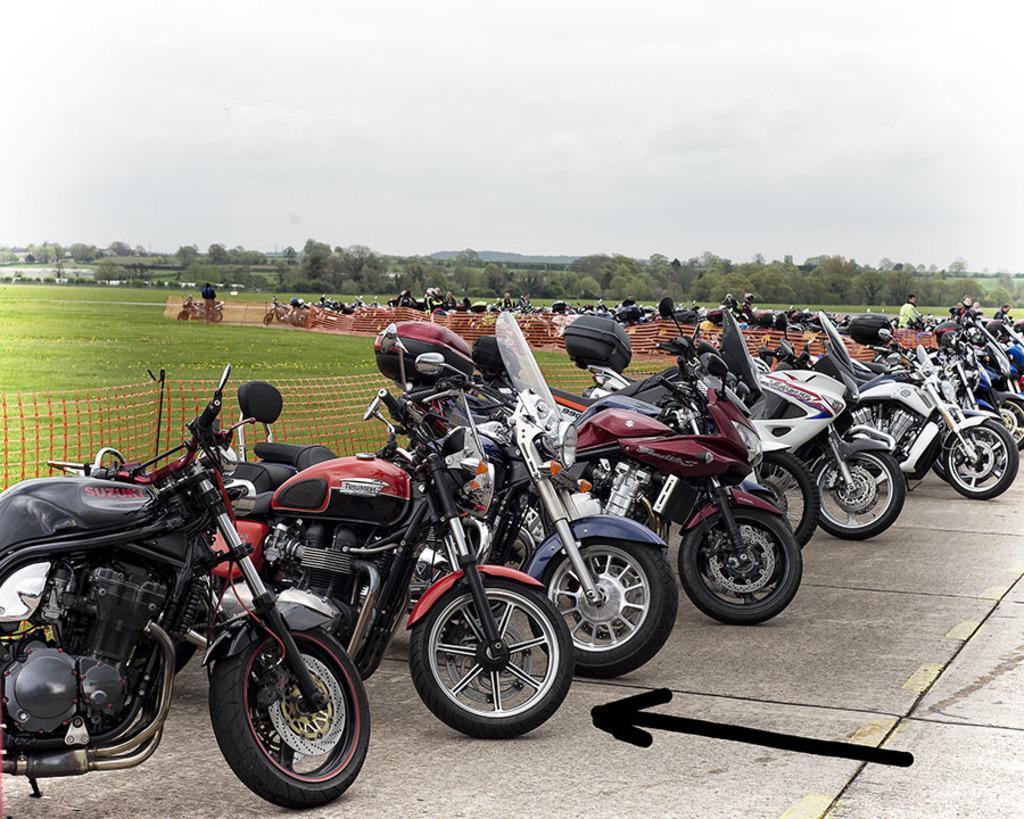Please provide a concise description of this image. This picture is clicked outside. In the foreground we can see the group of bikes parked on the ground. In the center we can see the green grass and the net. In the background there is a sky, trees and some persons. At the bottom right corner we can see the arrow on the image. 